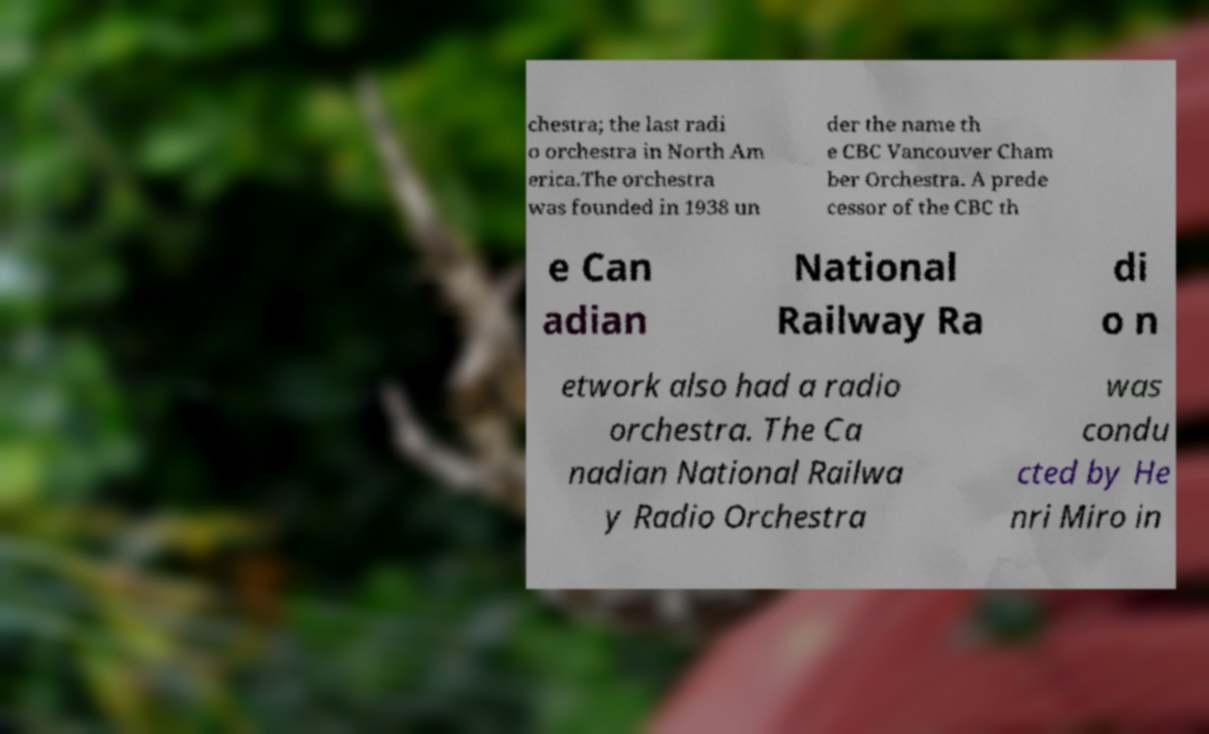Could you extract and type out the text from this image? chestra; the last radi o orchestra in North Am erica.The orchestra was founded in 1938 un der the name th e CBC Vancouver Cham ber Orchestra. A prede cessor of the CBC th e Can adian National Railway Ra di o n etwork also had a radio orchestra. The Ca nadian National Railwa y Radio Orchestra was condu cted by He nri Miro in 